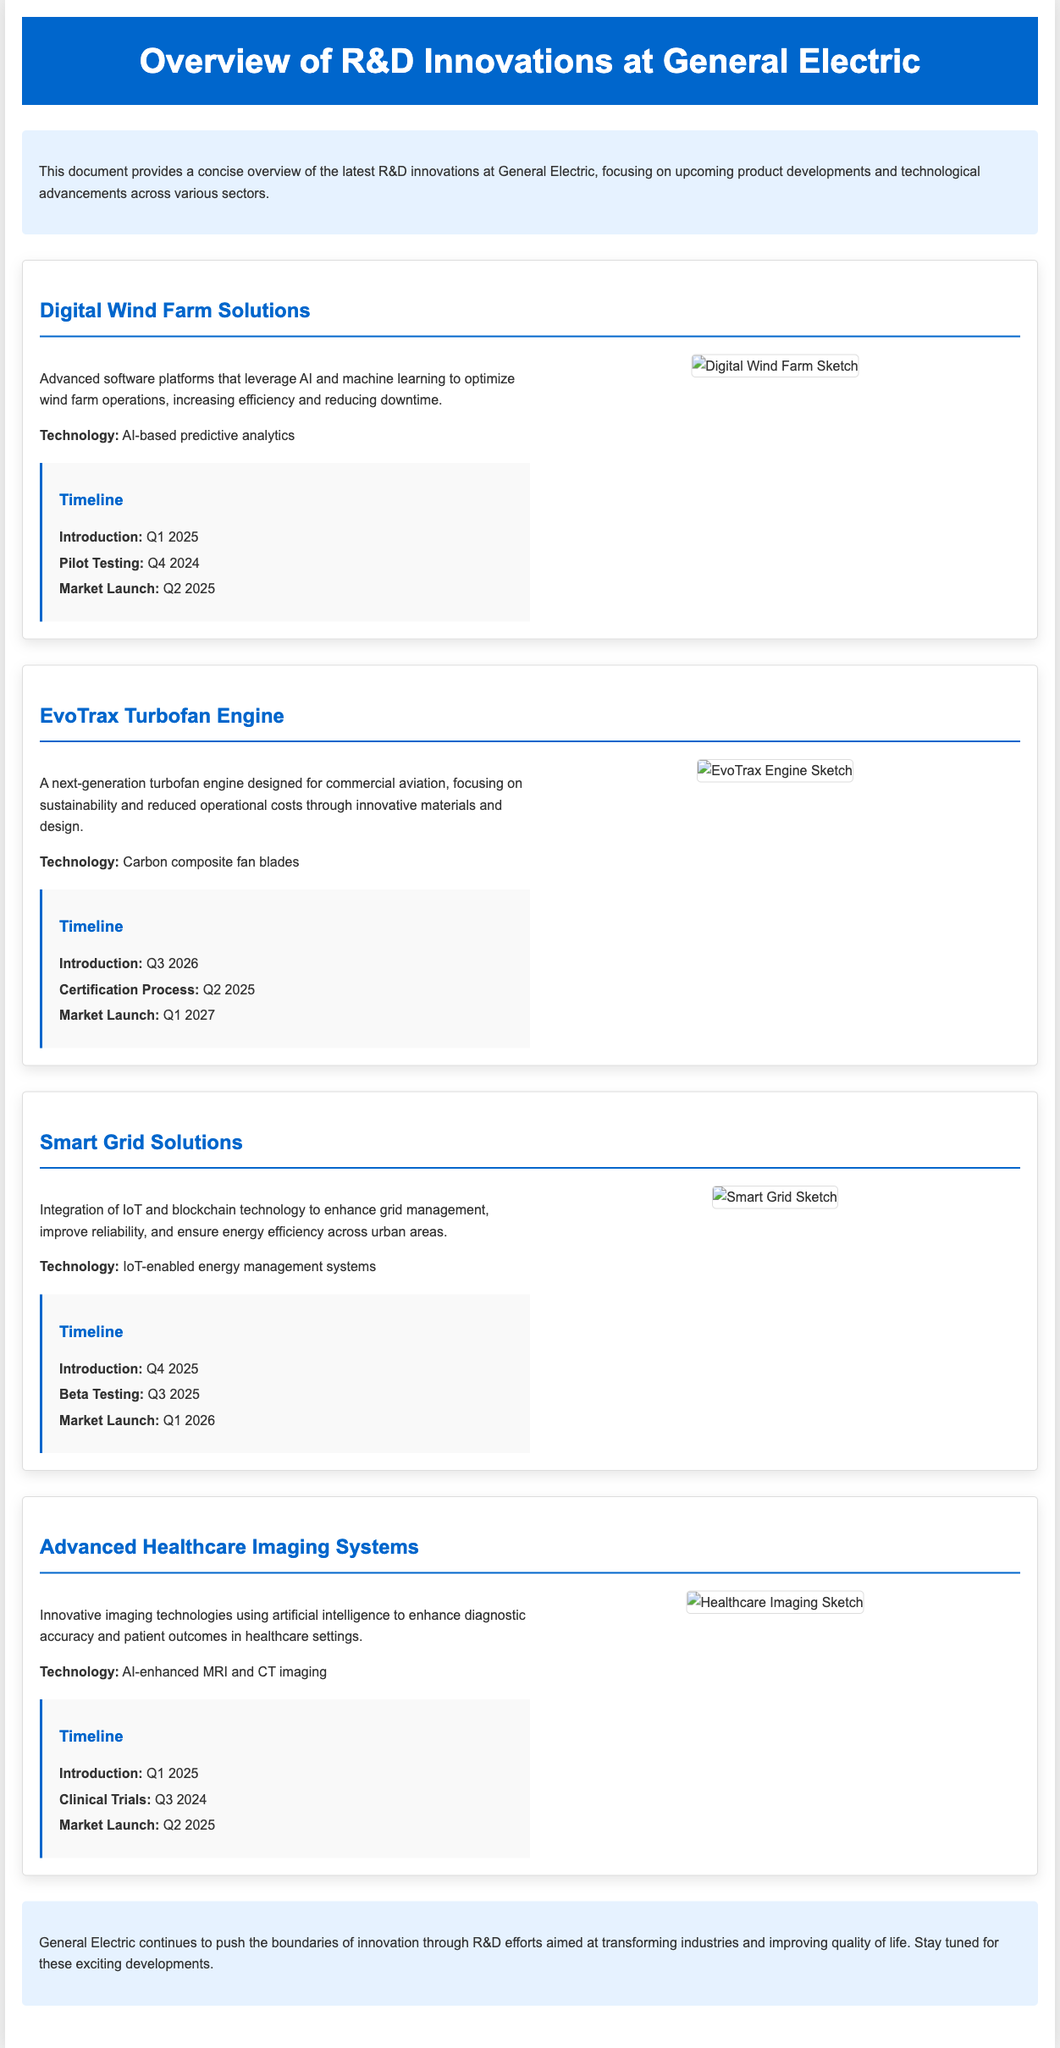what is the introduction date for Digital Wind Farm Solutions? The introduction date is specifically stated in the timeline of the document.
Answer: Q1 2025 what technology is used in the EvoTrax Turbofan Engine? The technology used is mentioned in the description of the innovation section.
Answer: Carbon composite fan blades when will the market launch of Smart Grid Solutions occur? The market launch date is specified in the timeline provided within the document.
Answer: Q1 2026 what phase comes before the market launch of Advanced Healthcare Imaging Systems? The phase mentioned is part of the timeline for this specific innovation.
Answer: Clinical Trials which innovation features AI-enhanced MRI and CT imaging? This is detailed in the description of one of the innovations in the document.
Answer: Advanced Healthcare Imaging Systems what is the focus of Digital Wind Farm Solutions? The focus is described in the text accompanying the innovation.
Answer: Optimize wind farm operations when will pilot testing begin for Digital Wind Farm Solutions? The timeline outlines the pilot testing timing in relation to the introduction.
Answer: Q4 2024 what is the main technological integration in Smart Grid Solutions? This information can be found in the core description explaining the innovation’s features.
Answer: IoT and blockchain technology how many phases are listed in the timeline for the EvoTrax Turbofan Engine? The number of phases can be counted from the timeline section in the document.
Answer: Three phases 